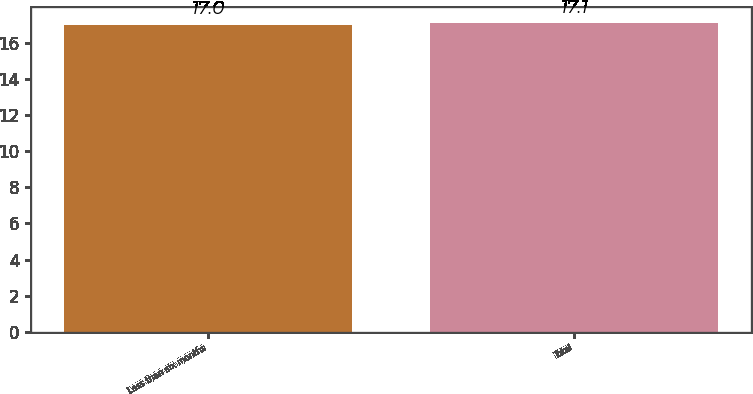Convert chart. <chart><loc_0><loc_0><loc_500><loc_500><bar_chart><fcel>Less than six months<fcel>Total<nl><fcel>17<fcel>17.1<nl></chart> 